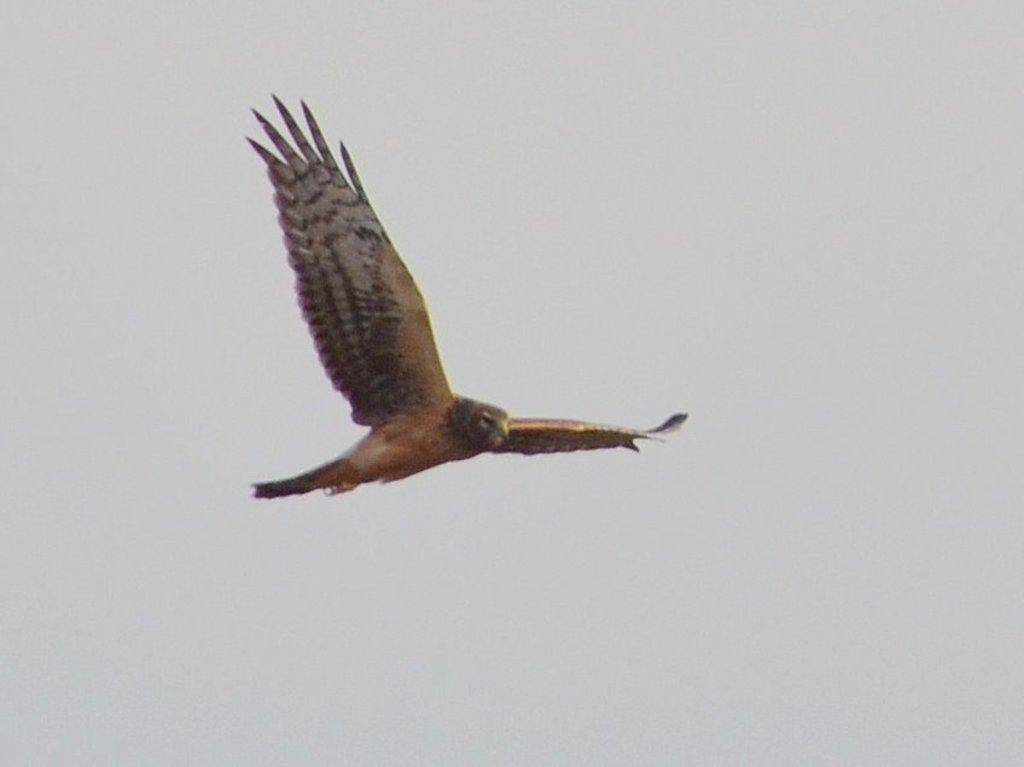In one or two sentences, can you explain what this image depicts? In this picture we can see an eagle flying, in the background there is sky. 